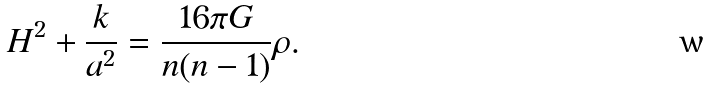Convert formula to latex. <formula><loc_0><loc_0><loc_500><loc_500>H ^ { 2 } + \frac { k } { a ^ { 2 } } = \frac { 1 6 \pi G } { n ( n - 1 ) } \rho .</formula> 